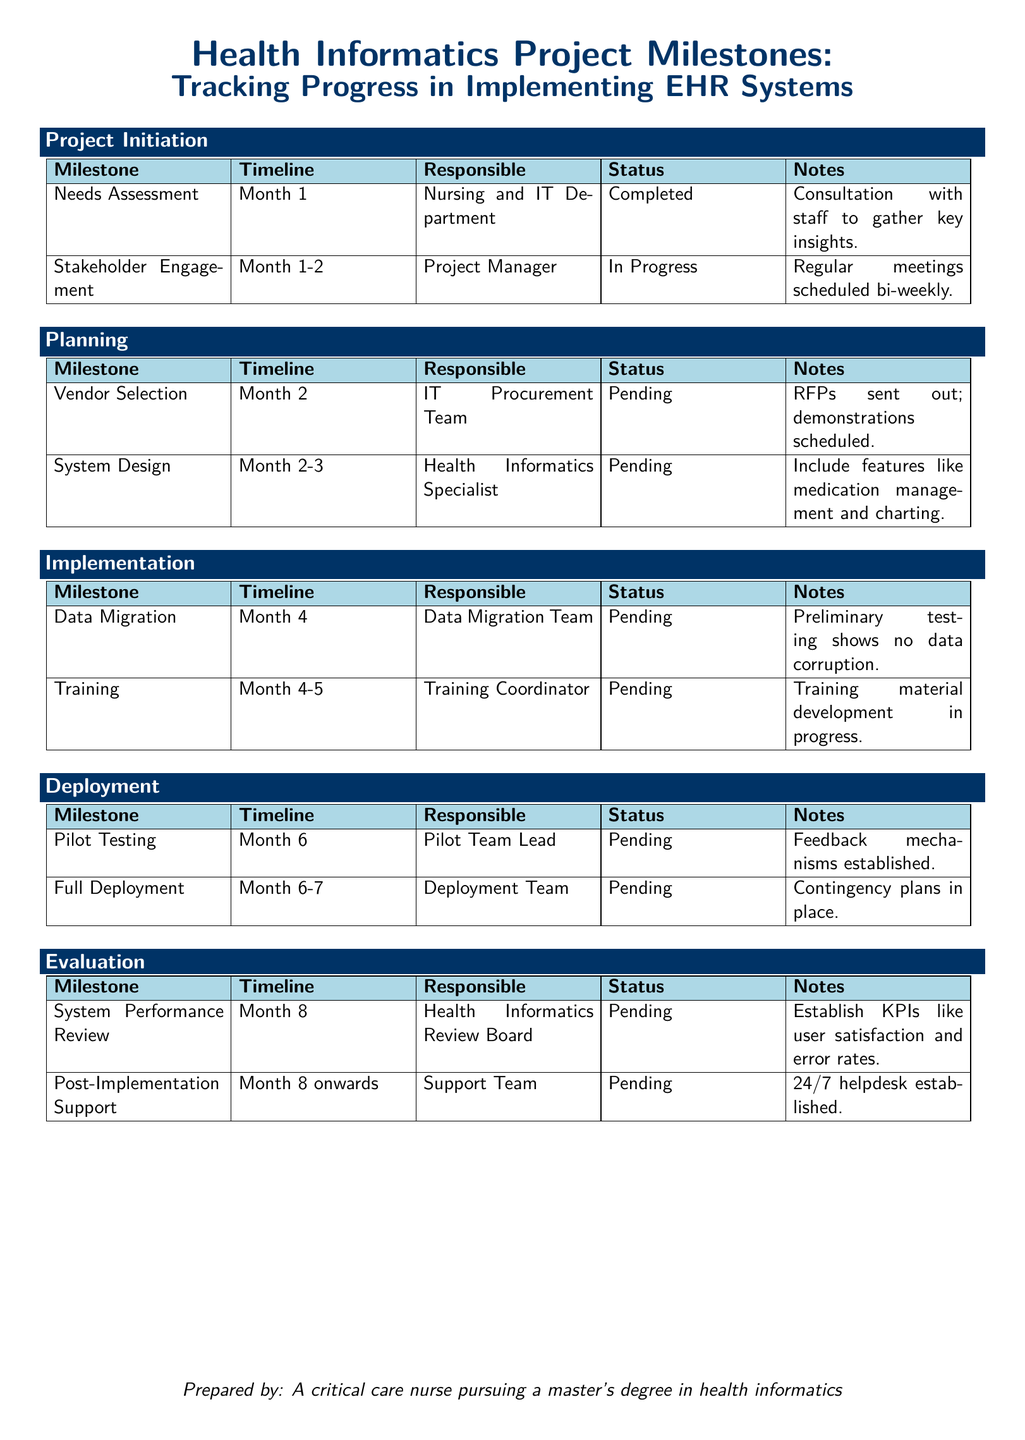What is the milestone for month 1? The milestone for month 1 includes Needs Assessment and Stakeholder Engagement.
Answer: Needs Assessment, Stakeholder Engagement Who is responsible for the Vendor Selection? The Vendor Selection is under the responsibility of the IT Procurement Team.
Answer: IT Procurement Team What is the status of Training? The status of Training is Pending.
Answer: Pending In which month is the Full Deployment scheduled? Full Deployment is scheduled between month 6 and month 7.
Answer: Month 6-7 What is the timeline for the System Performance Review? The timeline for the System Performance Review is month 8.
Answer: Month 8 Which team is responsible for post-implementation support? The Support Team is responsible for post-implementation support.
Answer: Support Team What feature is included in the System Design? Medication management is one of the features included in the System Design.
Answer: Medication management What has been established to monitor feedback during Pilot Testing? Feedback mechanisms have been established for the Pilot Testing.
Answer: Feedback mechanisms 